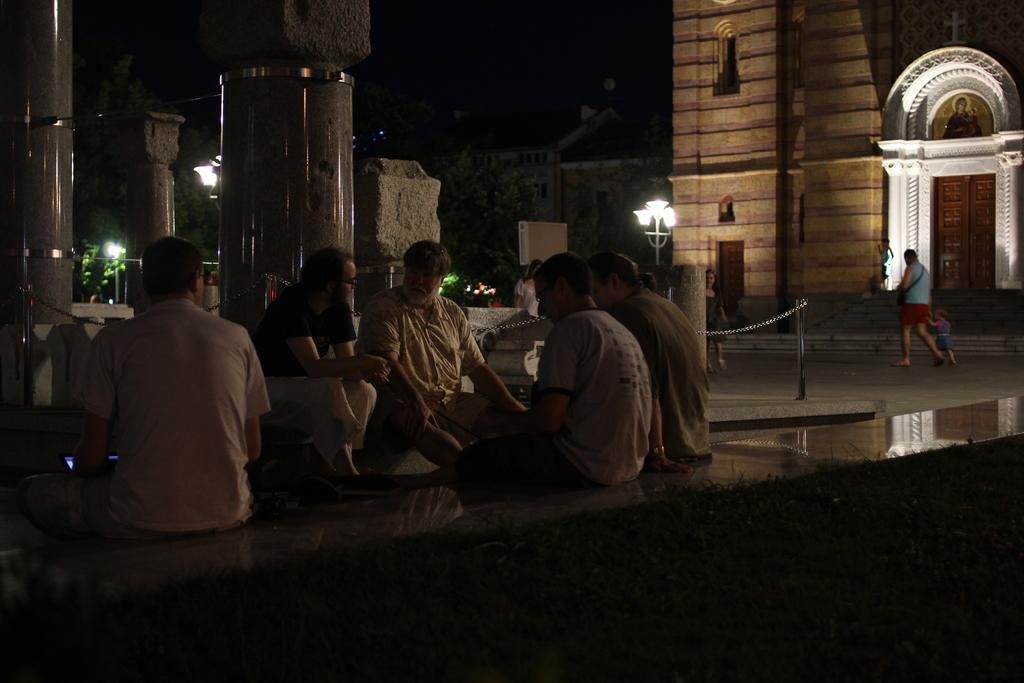What is the main subject of the image? The main subject of the image is a group of people. Where are the people located in the image? The people are sitting in the middle of the image. What can be seen in the background of the image? There are lights and buildings in the background of the image. Is there a railway visible in the image? There is no railway present in the image. Can you see any water in the image? There is no water visible in the image. 